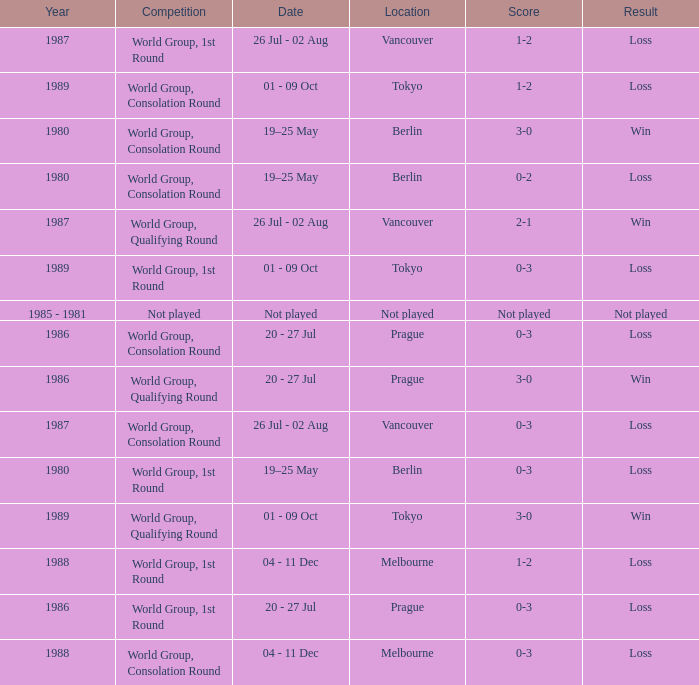What is the score when the result is loss, the year is 1980 and the competition is world group, consolation round? 0-2. 